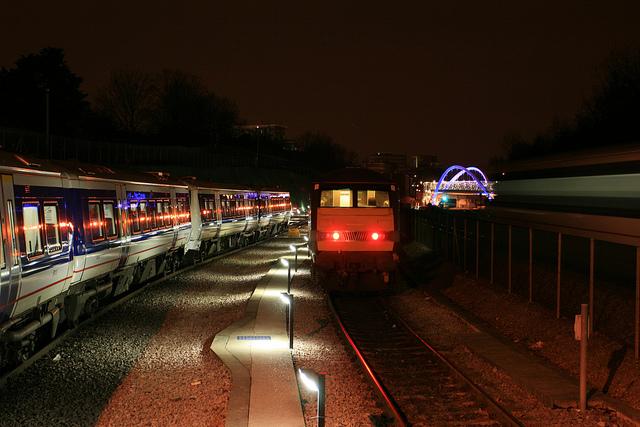Is it dark outside?
Write a very short answer. Yes. How many purple arcs are visible?
Answer briefly. 2. How many trains do you see?
Quick response, please. 2. 